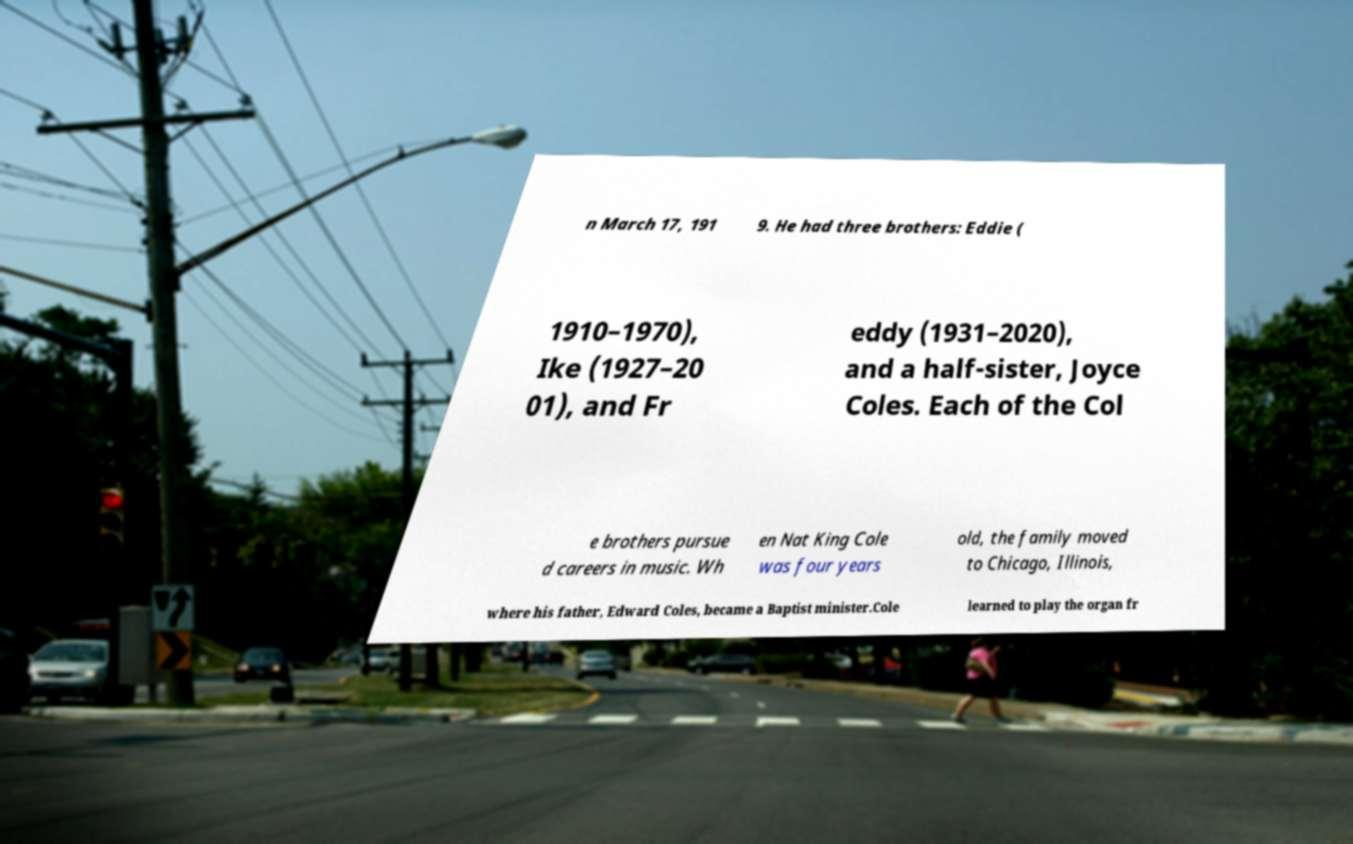What messages or text are displayed in this image? I need them in a readable, typed format. n March 17, 191 9. He had three brothers: Eddie ( 1910–1970), Ike (1927–20 01), and Fr eddy (1931–2020), and a half-sister, Joyce Coles. Each of the Col e brothers pursue d careers in music. Wh en Nat King Cole was four years old, the family moved to Chicago, Illinois, where his father, Edward Coles, became a Baptist minister.Cole learned to play the organ fr 